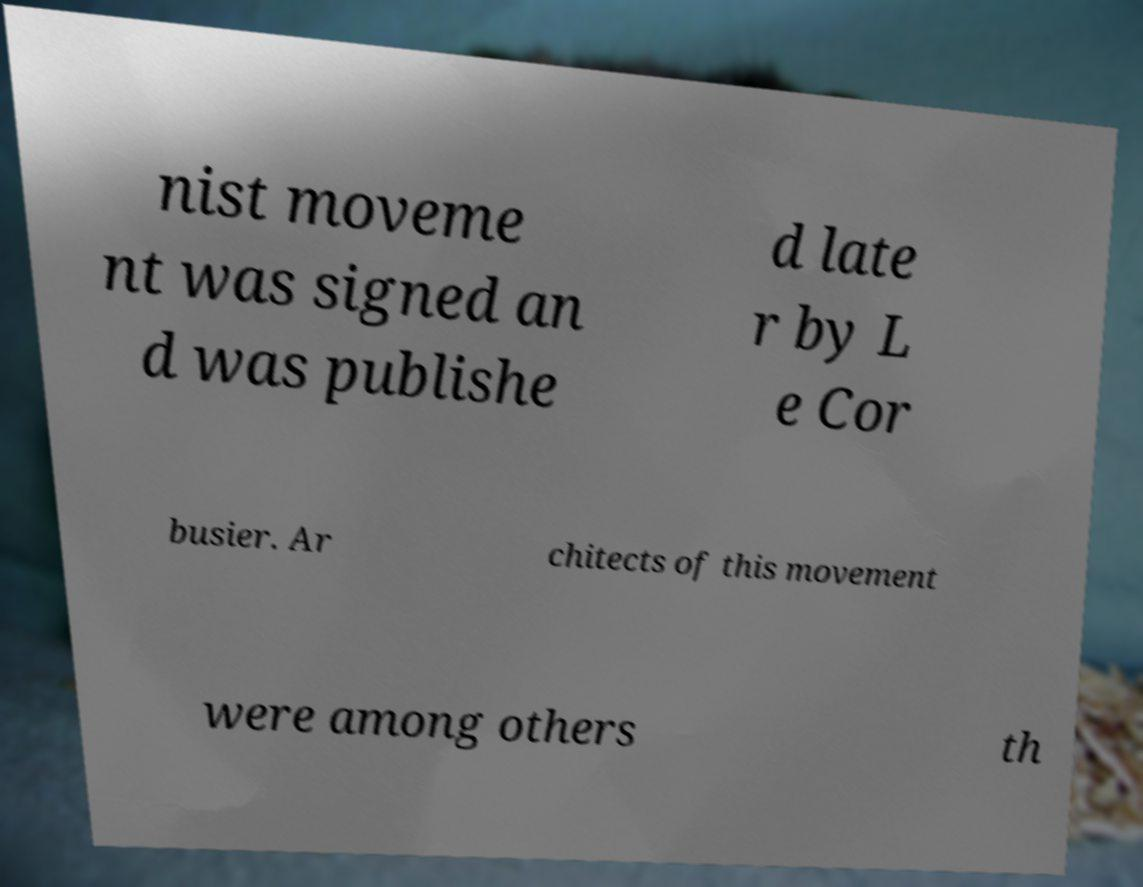Can you read and provide the text displayed in the image?This photo seems to have some interesting text. Can you extract and type it out for me? nist moveme nt was signed an d was publishe d late r by L e Cor busier. Ar chitects of this movement were among others th 